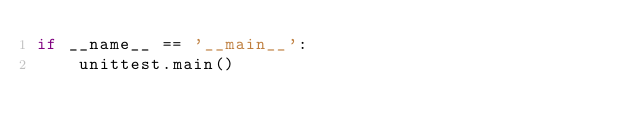<code> <loc_0><loc_0><loc_500><loc_500><_Python_>if __name__ == '__main__':
    unittest.main()
</code> 